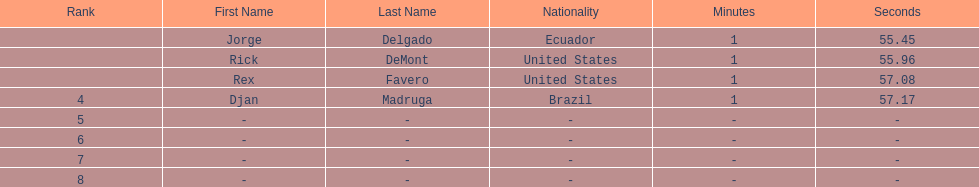Favero finished in 1:57.08. what was the next time? 1:57.17. 